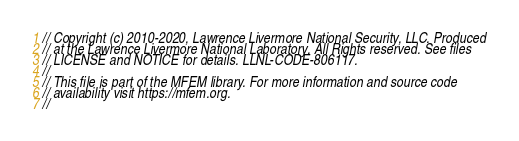<code> <loc_0><loc_0><loc_500><loc_500><_C++_>// Copyright (c) 2010-2020, Lawrence Livermore National Security, LLC. Produced
// at the Lawrence Livermore National Laboratory. All Rights reserved. See files
// LICENSE and NOTICE for details. LLNL-CODE-806117.
//
// This file is part of the MFEM library. For more information and source code
// availability visit https://mfem.org.
//</code> 